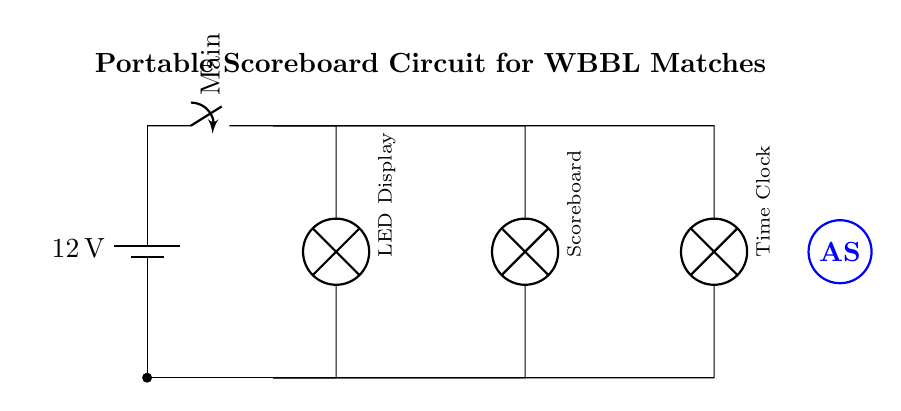What is the voltage of the battery? The circuit shows a battery labeled with a voltage of 12V. This is the potential supplied to the entire circuit.
Answer: 12V What are the components powered by the circuit? In the circuit diagram, there are three components listed: LED Display, Scoreboard, and Time Clock. These are all connected in parallel and will operate simultaneously when the circuit is closed.
Answer: LED Display, Scoreboard, Time Clock How many parallel branches are in the circuit? The diagram depicts three distinct parallel branches connected to the battery. Each branch corresponds to a different component, showing their parallel configuration.
Answer: Three What is the function of the main switch? The main switch in the circuit allows the user to control the entire circuit. When the switch is closed (in the ON position), the current flows to all connected components. If opened (OFF), the current stops flowing.
Answer: Control power to components What happens to the brightness of the LED Display if one component fails? In a parallel circuit like this one, if one component (like the Scoreboard or Time Clock) fails, the LED Display will continue to receive the full voltage from the battery and will remain lit. Therefore, the brightness of the LED Display stays unaffected.
Answer: It stays the same What does the simplified Adelaide Strikers logo represent in the circuit? The logo drawn in the circuit represents the Adelaide Strikers, a team in the WBBL, signifying that the scoreboard is specifically designed for their matches, enhancing the theme and purpose of the circuit.
Answer: Adelaide Strikers Why is a parallel circuit used for the scoreboard? A parallel circuit allows each component to operate independently. If one component fails, the others will still function normally, which is crucial for portable scoreboards during a match where continuous display of information is required.
Answer: Independent operation 